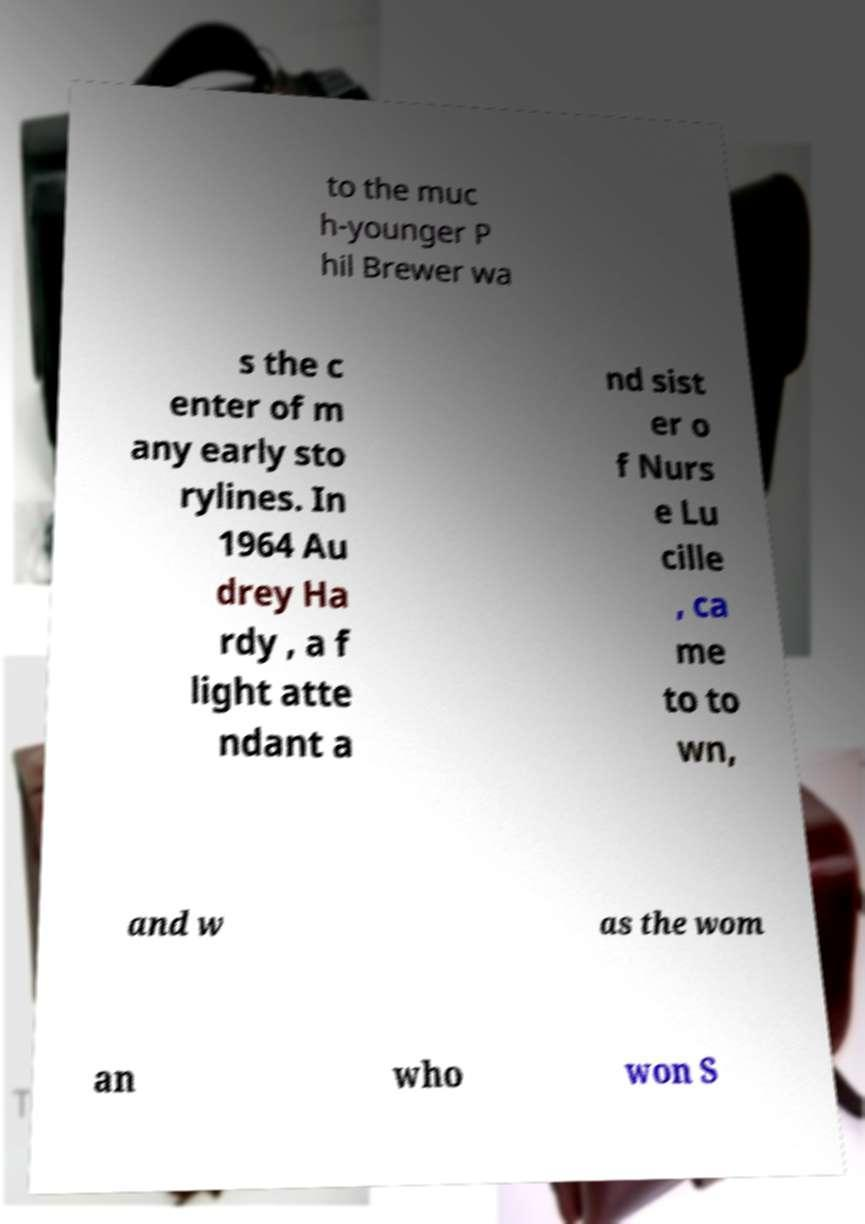What messages or text are displayed in this image? I need them in a readable, typed format. to the muc h-younger P hil Brewer wa s the c enter of m any early sto rylines. In 1964 Au drey Ha rdy , a f light atte ndant a nd sist er o f Nurs e Lu cille , ca me to to wn, and w as the wom an who won S 